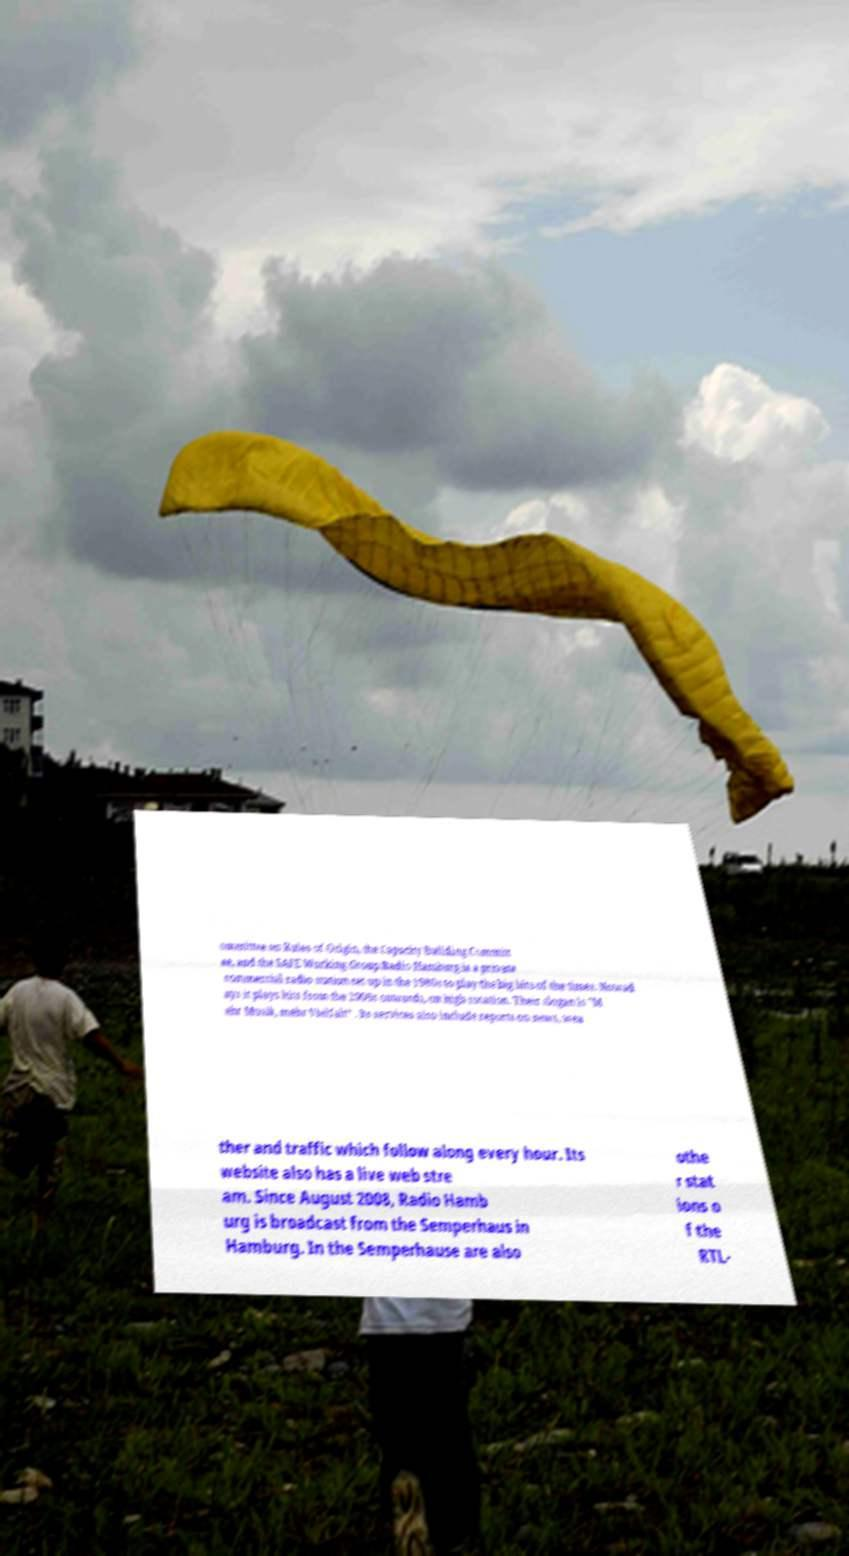Please read and relay the text visible in this image. What does it say? ommittee on Rules of Origin, the Capacity Building Committ ee, and the SAFE Working Group.Radio Hamburg is a private commercial radio station set up in the 1980s to play the big hits of the times. Nowad ays it plays hits from the 2000s onwards, on high rotation. Their slogan is "M ehr Musik, mehr Vielfalt“ . Its services also include reports on news, wea ther and traffic which follow along every hour. Its website also has a live web stre am. Since August 2008, Radio Hamb urg is broadcast from the Semperhaus in Hamburg. In the Semperhause are also othe r stat ions o f the RTL- 